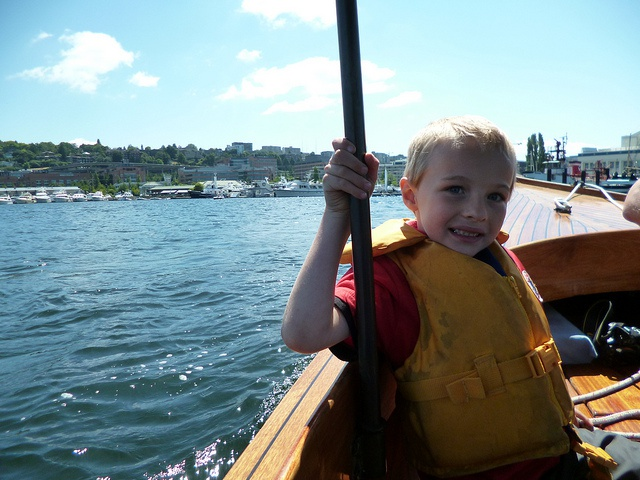Describe the objects in this image and their specific colors. I can see people in lightblue, black, maroon, and gray tones, boat in lightblue, black, maroon, lightgray, and tan tones, boat in lightblue, gray, lightgray, and darkgray tones, boat in lightblue, gray, and blue tones, and boat in lightblue, black, darkgray, and gray tones in this image. 